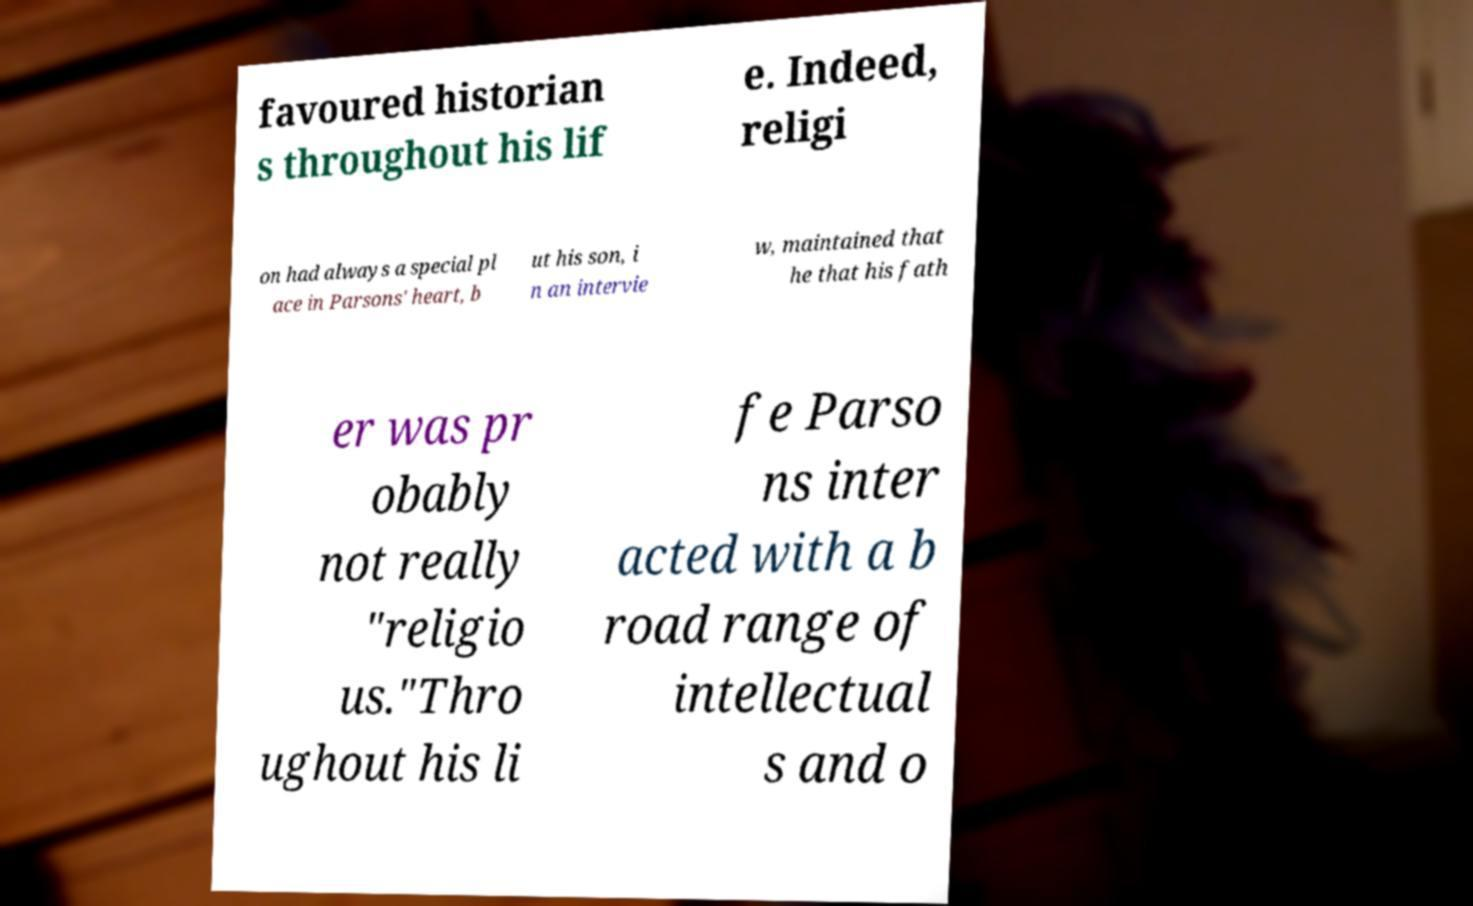Please read and relay the text visible in this image. What does it say? favoured historian s throughout his lif e. Indeed, religi on had always a special pl ace in Parsons' heart, b ut his son, i n an intervie w, maintained that he that his fath er was pr obably not really "religio us."Thro ughout his li fe Parso ns inter acted with a b road range of intellectual s and o 